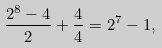<formula> <loc_0><loc_0><loc_500><loc_500>\frac { 2 ^ { 8 } - 4 } { 2 } + \frac { 4 } { 4 } = 2 ^ { 7 } - 1 ,</formula> 